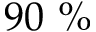<formula> <loc_0><loc_0><loc_500><loc_500>9 0 \%</formula> 